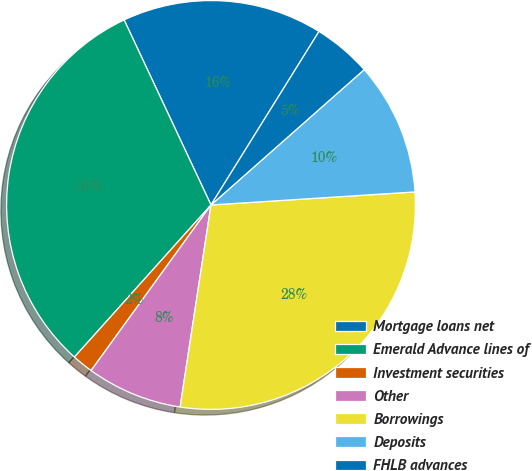Convert chart to OTSL. <chart><loc_0><loc_0><loc_500><loc_500><pie_chart><fcel>Mortgage loans net<fcel>Emerald Advance lines of<fcel>Investment securities<fcel>Other<fcel>Borrowings<fcel>Deposits<fcel>FHLB advances<nl><fcel>15.85%<fcel>31.37%<fcel>1.67%<fcel>7.56%<fcel>28.43%<fcel>10.5%<fcel>4.62%<nl></chart> 